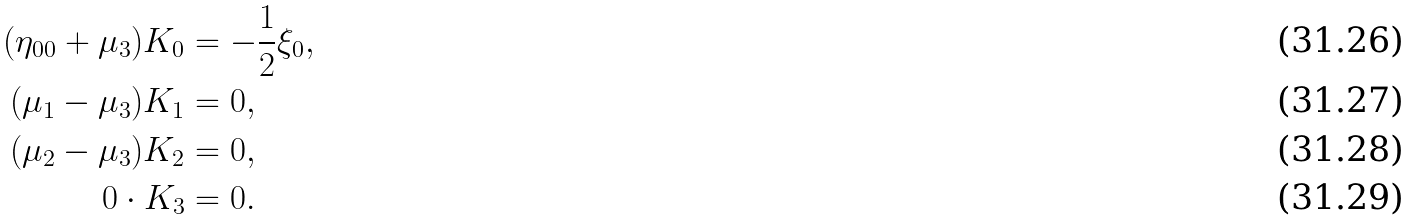<formula> <loc_0><loc_0><loc_500><loc_500>( \eta _ { 0 0 } + \mu _ { 3 } ) K _ { 0 } & = - \frac { 1 } { 2 } \xi _ { 0 } , \\ ( \mu _ { 1 } - \mu _ { 3 } ) K _ { 1 } & = 0 , \\ ( \mu _ { 2 } - \mu _ { 3 } ) K _ { 2 } & = 0 , \\ 0 \cdot K _ { 3 } & = 0 .</formula> 